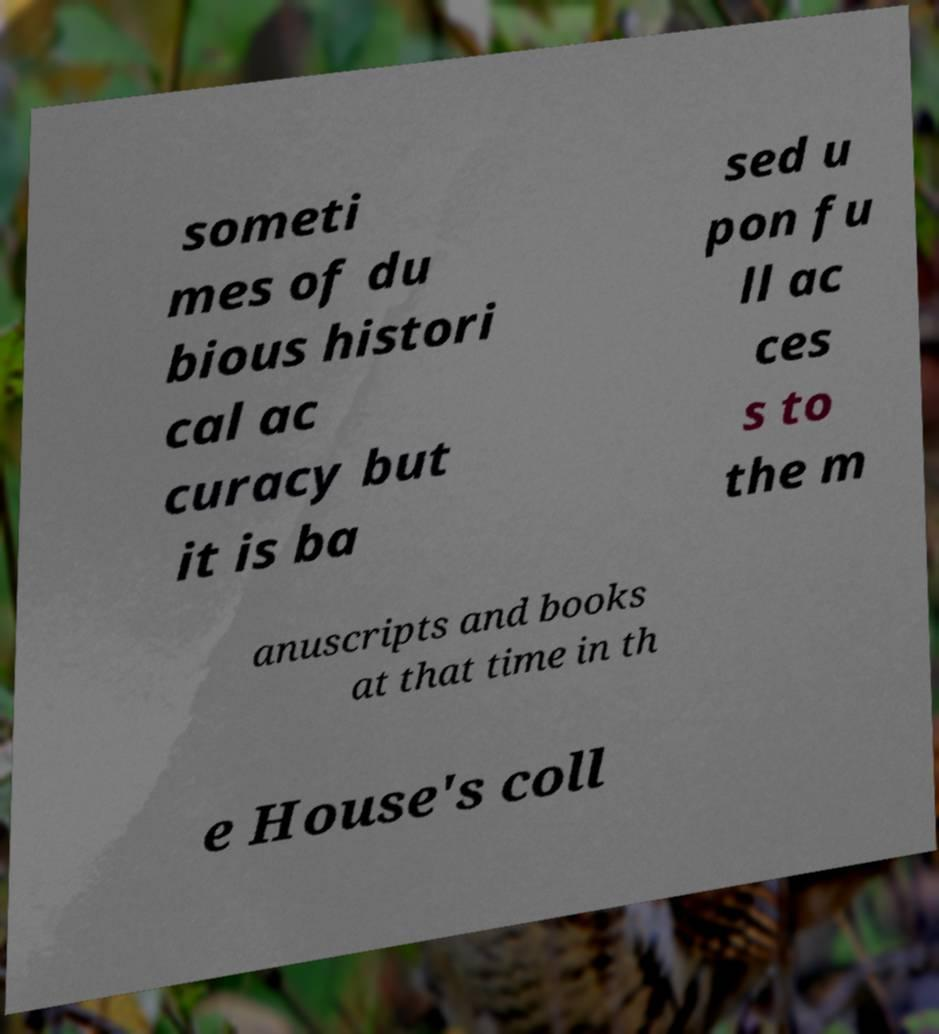Can you read and provide the text displayed in the image?This photo seems to have some interesting text. Can you extract and type it out for me? someti mes of du bious histori cal ac curacy but it is ba sed u pon fu ll ac ces s to the m anuscripts and books at that time in th e House's coll 